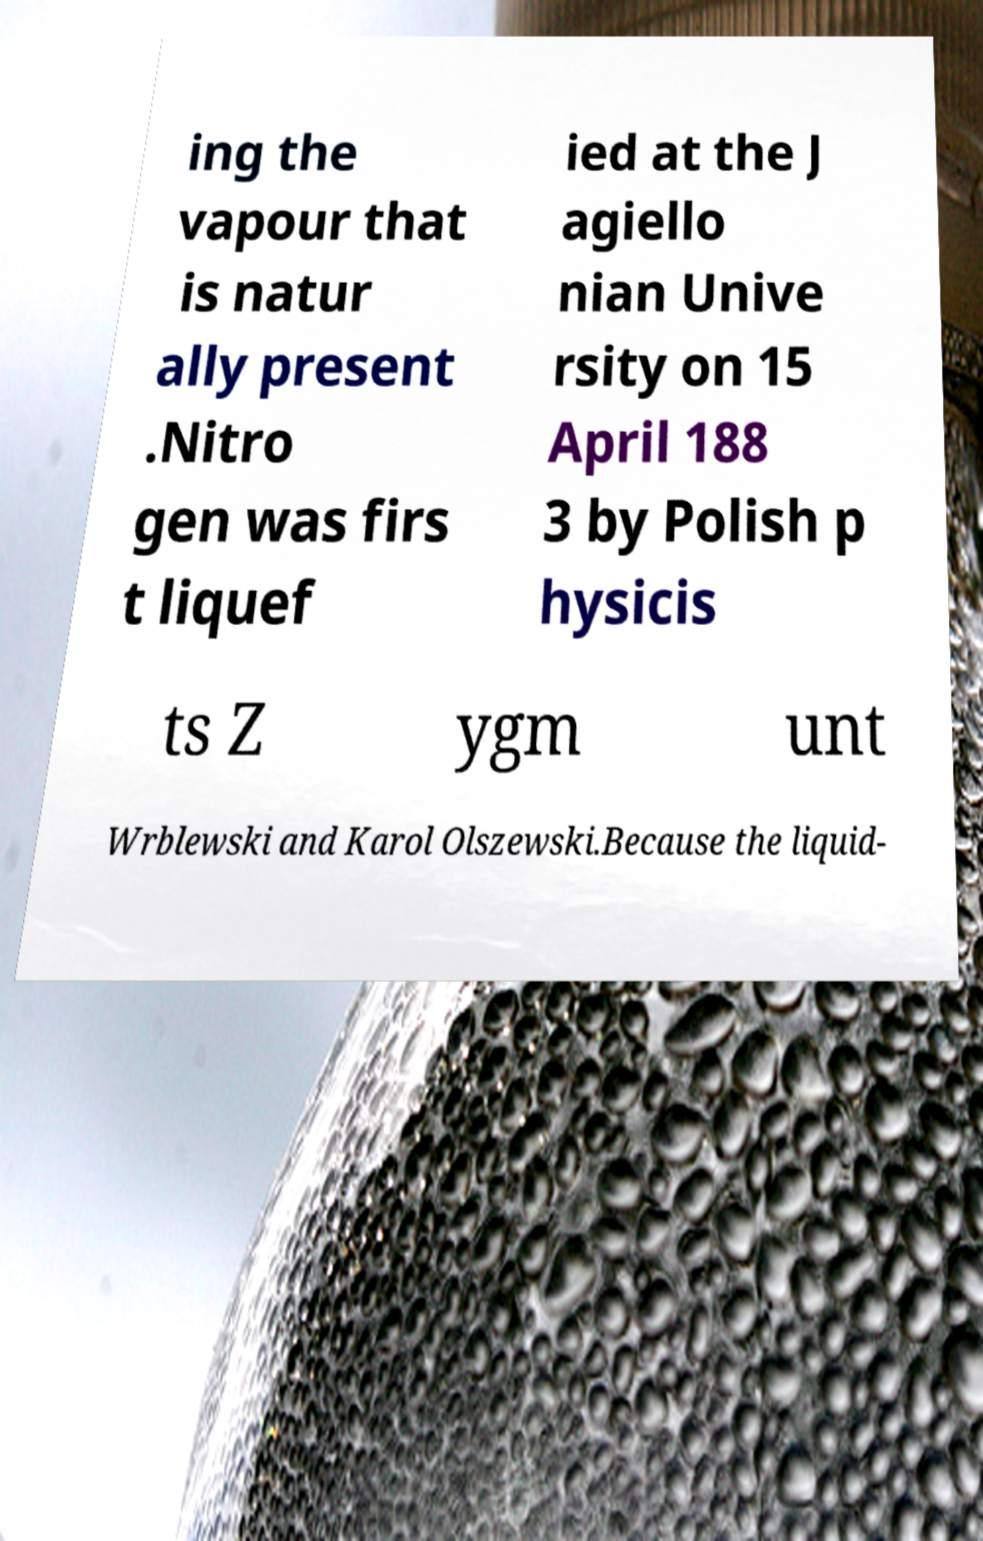Please read and relay the text visible in this image. What does it say? ing the vapour that is natur ally present .Nitro gen was firs t liquef ied at the J agiello nian Unive rsity on 15 April 188 3 by Polish p hysicis ts Z ygm unt Wrblewski and Karol Olszewski.Because the liquid- 